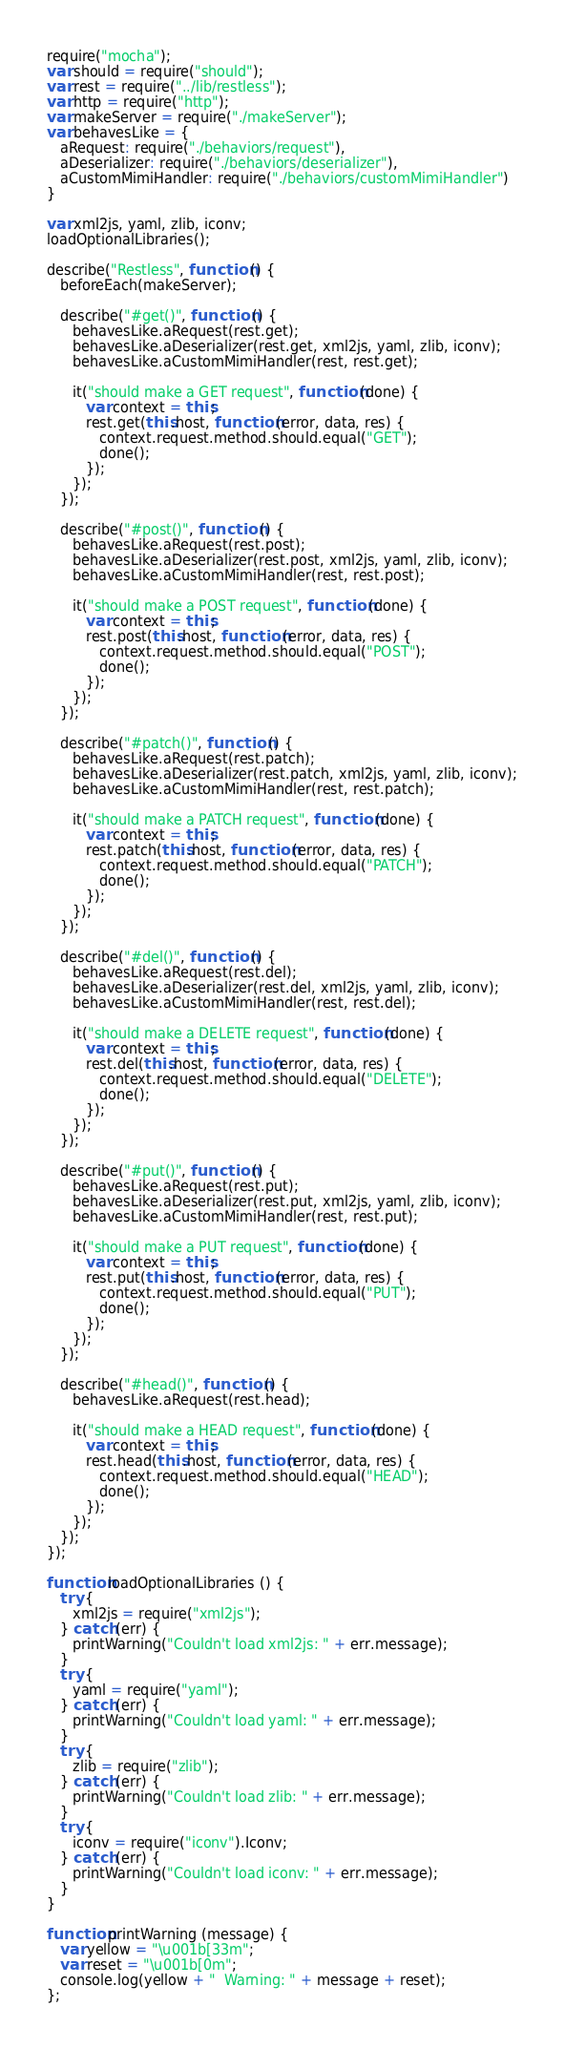<code> <loc_0><loc_0><loc_500><loc_500><_JavaScript_>require("mocha");
var should = require("should");
var rest = require("../lib/restless");
var http = require("http");
var makeServer = require("./makeServer");
var behavesLike = {
   aRequest: require("./behaviors/request"),
   aDeserializer: require("./behaviors/deserializer"),
   aCustomMimiHandler: require("./behaviors/customMimiHandler")
}

var xml2js, yaml, zlib, iconv;
loadOptionalLibraries();

describe("Restless", function () {
   beforeEach(makeServer);

   describe("#get()", function () {
      behavesLike.aRequest(rest.get);
      behavesLike.aDeserializer(rest.get, xml2js, yaml, zlib, iconv);
      behavesLike.aCustomMimiHandler(rest, rest.get);

      it("should make a GET request", function (done) {
         var context = this;
         rest.get(this.host, function (error, data, res) {
            context.request.method.should.equal("GET");
            done();
         });
      });
   });

   describe("#post()", function () {
      behavesLike.aRequest(rest.post);
      behavesLike.aDeserializer(rest.post, xml2js, yaml, zlib, iconv);
      behavesLike.aCustomMimiHandler(rest, rest.post);

      it("should make a POST request", function (done) {
         var context = this;
         rest.post(this.host, function (error, data, res) {
            context.request.method.should.equal("POST");
            done();
         });
      });
   });

   describe("#patch()", function () {
      behavesLike.aRequest(rest.patch);
      behavesLike.aDeserializer(rest.patch, xml2js, yaml, zlib, iconv);
      behavesLike.aCustomMimiHandler(rest, rest.patch);

      it("should make a PATCH request", function (done) {
         var context = this;
         rest.patch(this.host, function (error, data, res) {
            context.request.method.should.equal("PATCH");
            done();
         });
      });
   });

   describe("#del()", function () {
      behavesLike.aRequest(rest.del);
      behavesLike.aDeserializer(rest.del, xml2js, yaml, zlib, iconv);
      behavesLike.aCustomMimiHandler(rest, rest.del);

      it("should make a DELETE request", function (done) {
         var context = this;
         rest.del(this.host, function (error, data, res) {
            context.request.method.should.equal("DELETE");
            done();
         });
      });
   });

   describe("#put()", function () {
      behavesLike.aRequest(rest.put);
      behavesLike.aDeserializer(rest.put, xml2js, yaml, zlib, iconv);
      behavesLike.aCustomMimiHandler(rest, rest.put);

      it("should make a PUT request", function (done) {
         var context = this;
         rest.put(this.host, function (error, data, res) {
            context.request.method.should.equal("PUT");
            done();
         });
      });
   });

   describe("#head()", function () {
      behavesLike.aRequest(rest.head);

      it("should make a HEAD request", function (done) {
         var context = this;
         rest.head(this.host, function (error, data, res) {
            context.request.method.should.equal("HEAD");
            done();
         });
      });
   });
});

function loadOptionalLibraries () {
   try {
      xml2js = require("xml2js"); 
   } catch (err) { 
      printWarning("Couldn't load xml2js: " + err.message);
   }
   try {
      yaml = require("yaml"); 
   } catch (err) { 
      printWarning("Couldn't load yaml: " + err.message);
   }
   try {
      zlib = require("zlib");
   } catch (err) {
      printWarning("Couldn't load zlib: " + err.message); 
   }
   try {
      iconv = require("iconv").Iconv;
   } catch (err) {
      printWarning("Couldn't load iconv: " + err.message); 
   }
}

function printWarning (message) {
   var yellow = "\u001b[33m";
   var reset = "\u001b[0m";
   console.log(yellow + "  Warning: " + message + reset);
};</code> 